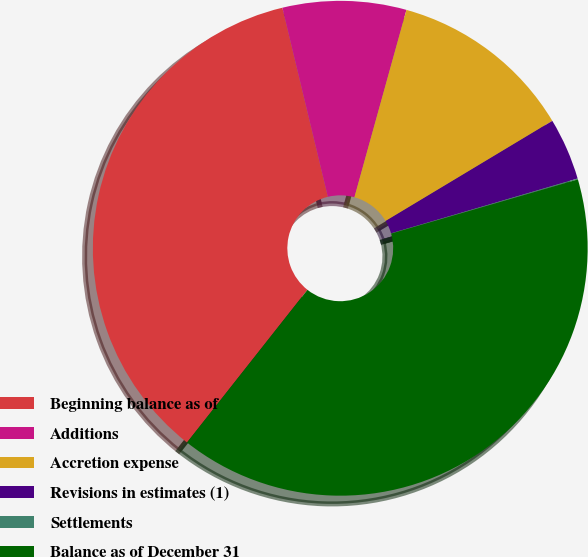Convert chart to OTSL. <chart><loc_0><loc_0><loc_500><loc_500><pie_chart><fcel>Beginning balance as of<fcel>Additions<fcel>Accretion expense<fcel>Revisions in estimates (1)<fcel>Settlements<fcel>Balance as of December 31<nl><fcel>35.61%<fcel>8.07%<fcel>12.08%<fcel>4.06%<fcel>0.06%<fcel>40.12%<nl></chart> 